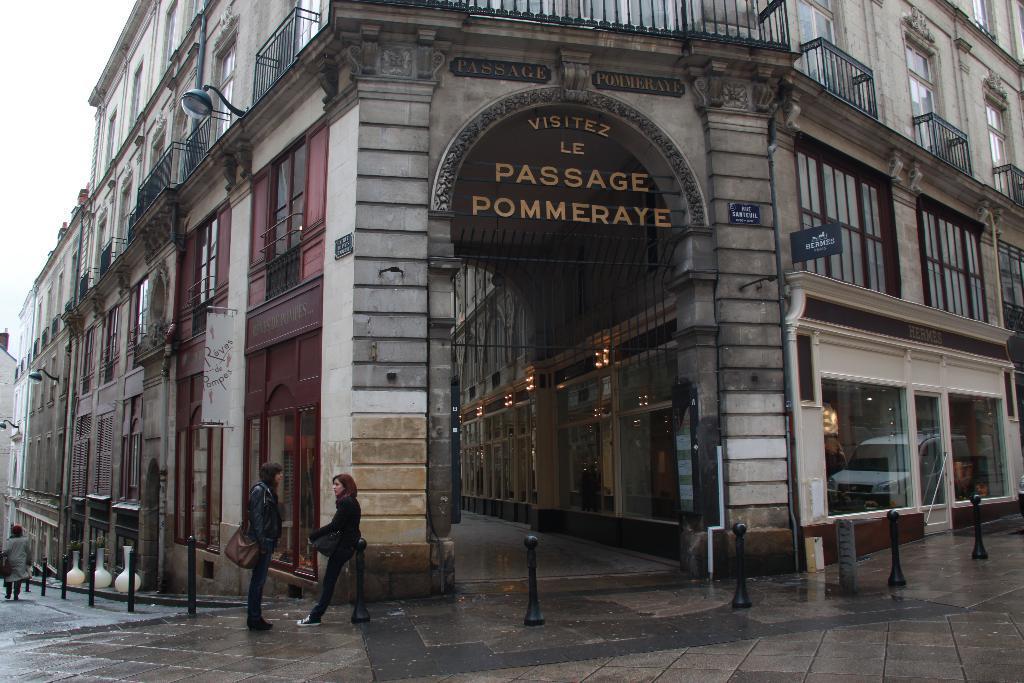How would you summarize this image in a sentence or two? There are two persons standing on the floor, near a pole and building which is having glass windows and hoardings. There are poles on the footpath. In the background, there is a person walking on the footpath and there is sky. 